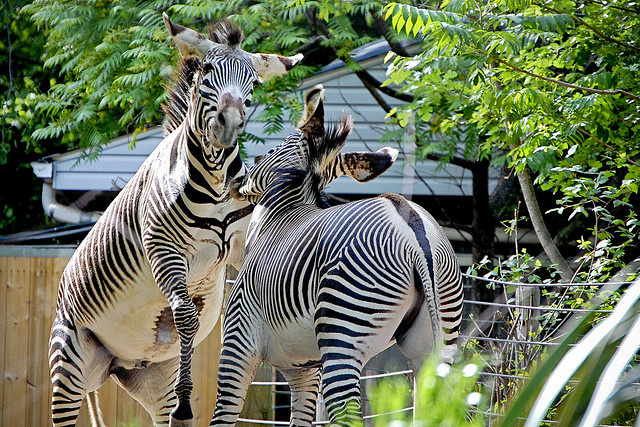<image>Why do zebra  look black and white? I don't know why zebras look black and white. It could be their unique color, their stripes, or for camouflage. Why do zebra  look black and white? I don't know why zebras look black and white. It can be because of their stripes or a way they are. 